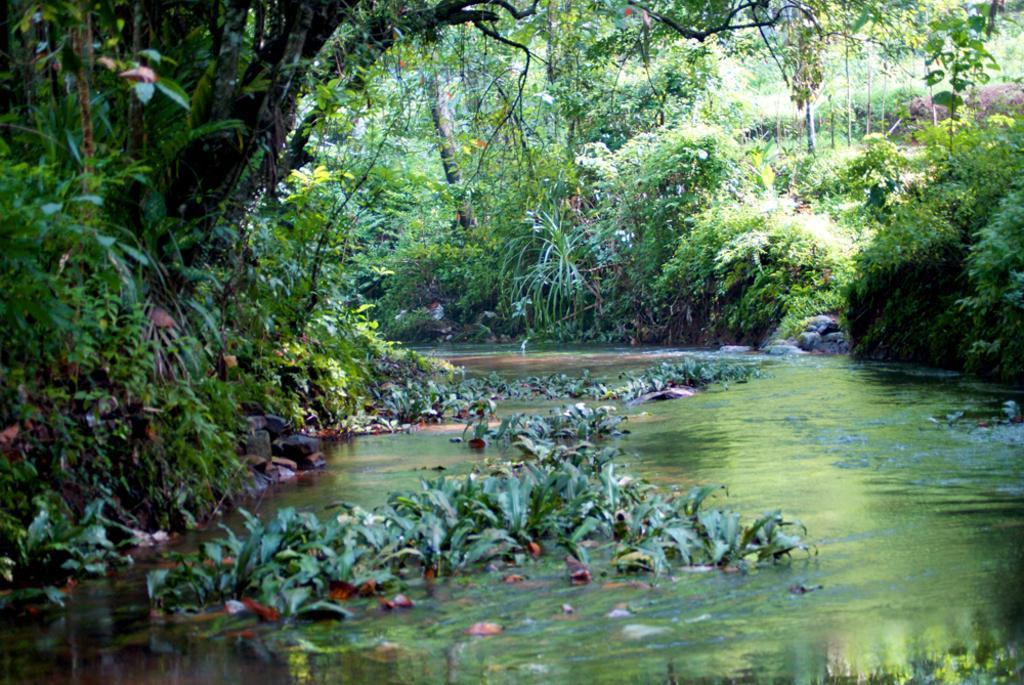Describe this image in one or two sentences. In this image, we can see trees and at the bottom, there are some plants in the water. 